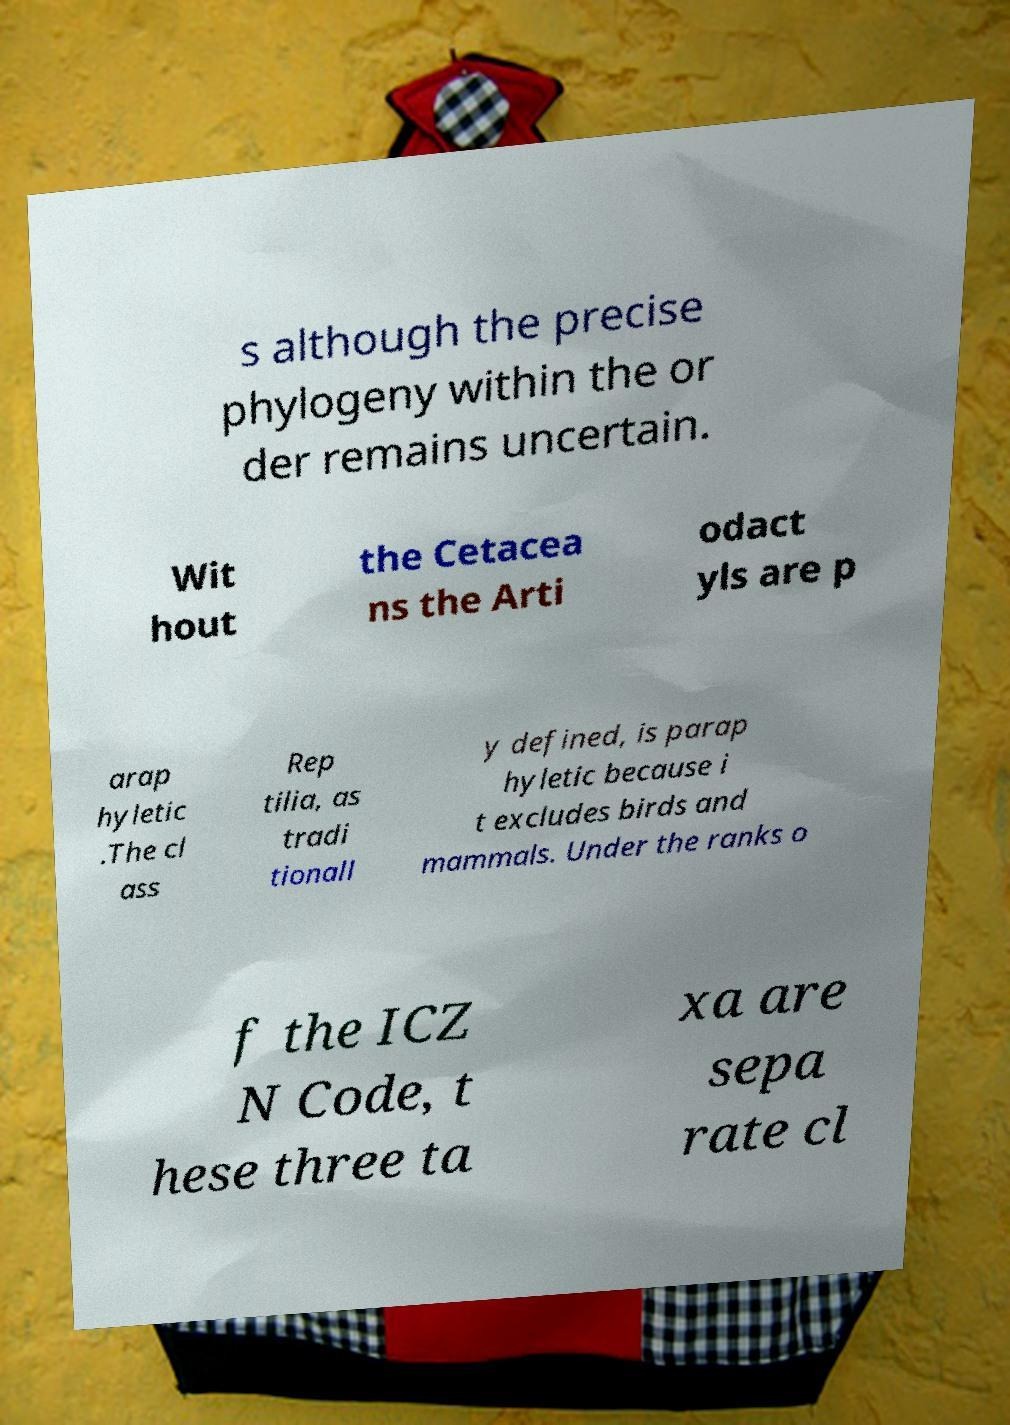Could you assist in decoding the text presented in this image and type it out clearly? s although the precise phylogeny within the or der remains uncertain. Wit hout the Cetacea ns the Arti odact yls are p arap hyletic .The cl ass Rep tilia, as tradi tionall y defined, is parap hyletic because i t excludes birds and mammals. Under the ranks o f the ICZ N Code, t hese three ta xa are sepa rate cl 